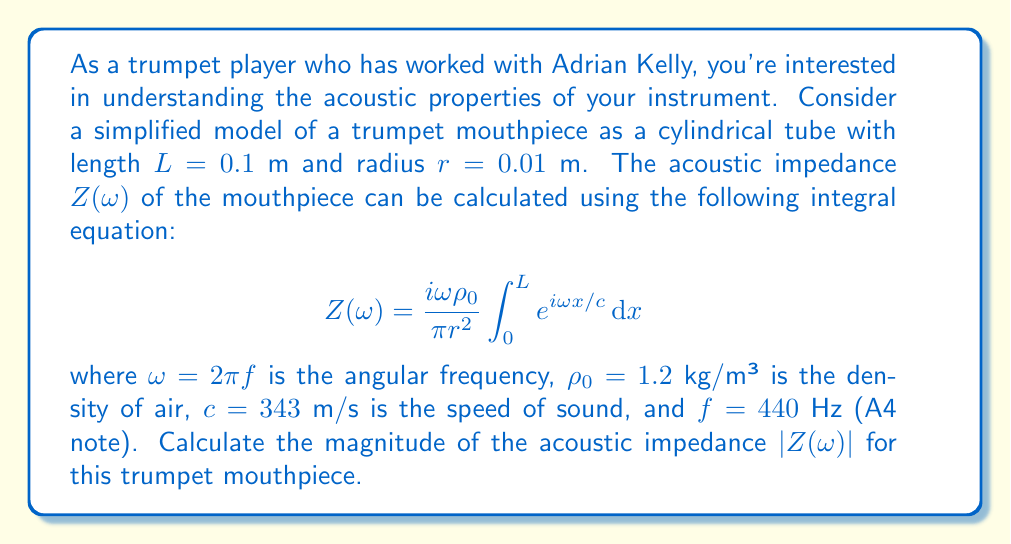Provide a solution to this math problem. Let's approach this step-by-step:

1) First, we need to calculate $\omega$:
   $$\omega = 2\pi f = 2\pi(440) \approx 2763.89 \text{ rad/s}$$

2) Now, let's solve the integral:
   $$\int_0^L e^{i\omega x/c} dx = \frac{c}{i\omega}[e^{i\omega x/c}]_0^L = \frac{c}{i\omega}(e^{i\omega L/c} - 1)$$

3) Substituting this back into the original equation:
   $$Z(\omega) = \frac{i\omega\rho_0}{\pi r^2} \cdot \frac{c}{i\omega}(e^{i\omega L/c} - 1)$$

4) Simplifying:
   $$Z(\omega) = \frac{\rho_0 c}{\pi r^2}(e^{i\omega L/c} - 1)$$

5) Let's substitute the values:
   $$Z(\omega) = \frac{1.2 \cdot 343}{\pi \cdot 0.01^2}(e^{i\cdot 2763.89 \cdot 0.1 / 343} - 1)$$

6) Simplify:
   $$Z(\omega) = 1309836.74(e^{0.8058i} - 1)$$

7) To find the magnitude, we need to calculate:
   $$|Z(\omega)| = 1309836.74 \cdot |e^{0.8058i} - 1|$$

8) Using Euler's formula, $e^{ix} = \cos x + i\sin x$:
   $$|Z(\omega)| = 1309836.74 \cdot \sqrt{(\cos 0.8058 - 1)^2 + (\sin 0.8058)^2}$$

9) Calculating:
   $$|Z(\omega)| = 1309836.74 \cdot 0.7206 \approx 943665.95 \text{ Pa·s/m³}$$
Answer: $943666 \text{ Pa·s/m³}$ 